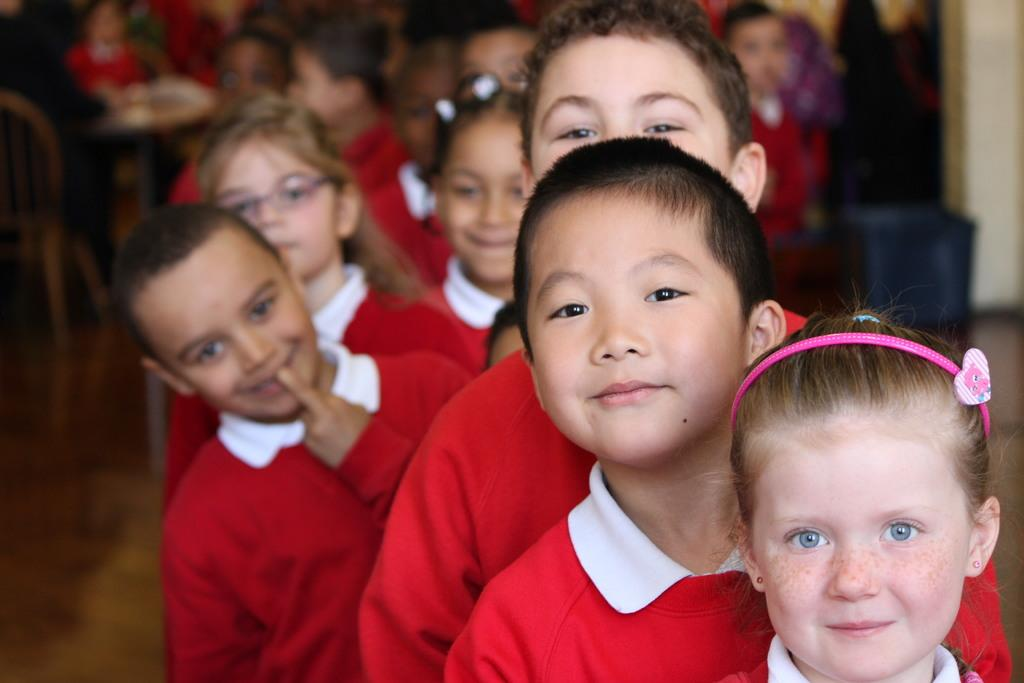How many people are in the image? There is a group of people in the image, but the exact number cannot be determined from the provided facts. What are the people in the image doing? The people are on the floor in the image. What furniture is visible in the image? There are chairs and a table in the image. What other objects can be seen in the image? There is a box in the image. What is the setting of the image? The image may have been taken in a hall, as indicated by the presence of a wall visible in the image. What type of rifle is being used by the people in the image? There is no rifle present in the image; the people are on the floor, and no weapons are visible. What rate is being discussed by the people in the image? There is no discussion or mention of a rate in the image; the focus is on the people's position on the floor and the surrounding furniture and objects. 